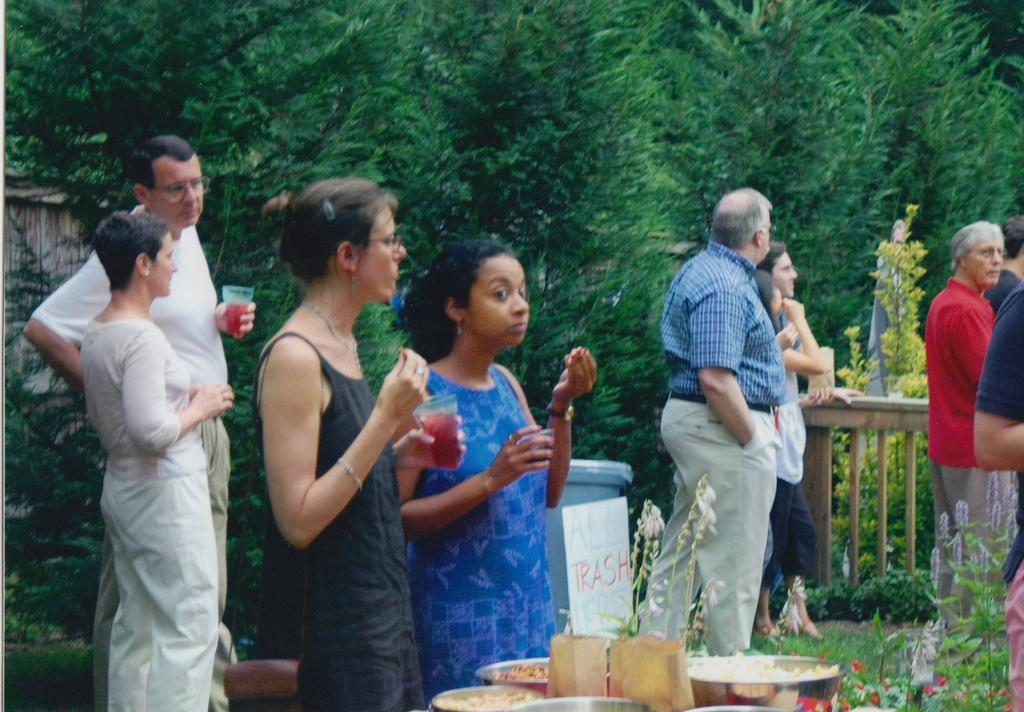How many people are present in the image? There are many people in the image. What are the people holding in their hands? The people are holding juice glasses. What can be seen in the background of the image? There are dishes with food items and trees visible in the background. What type of mark can be seen on the railway in the image? There is no railway present in the image, so it is not possible to determine if there is a mark on it. 